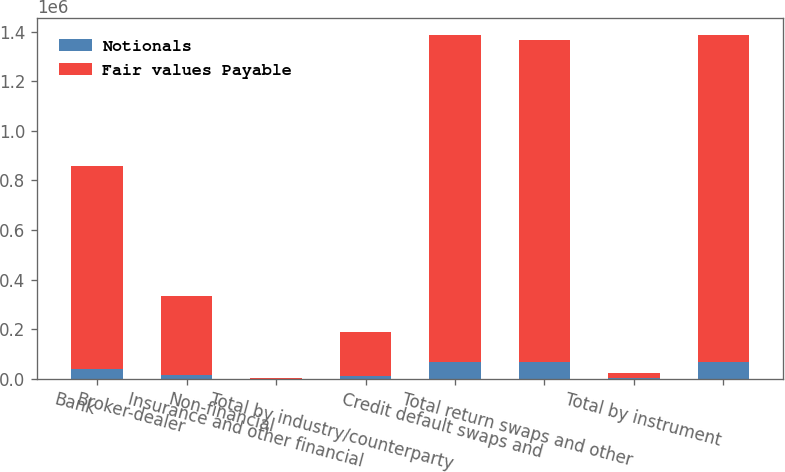Convert chart to OTSL. <chart><loc_0><loc_0><loc_500><loc_500><stacked_bar_chart><ecel><fcel>Bank<fcel>Broker-dealer<fcel>Non-financial<fcel>Insurance and other financial<fcel>Total by industry/counterparty<fcel>Credit default swaps and<fcel>Total return swaps and other<fcel>Total by instrument<nl><fcel>Notionals<fcel>37586<fcel>15428<fcel>93<fcel>10108<fcel>65129<fcel>64840<fcel>289<fcel>65129<nl><fcel>Fair values Payable<fcel>820211<fcel>319625<fcel>1277<fcel>177171<fcel>1.32269e+06<fcel>1.30151e+06<fcel>21179<fcel>1.32269e+06<nl></chart> 